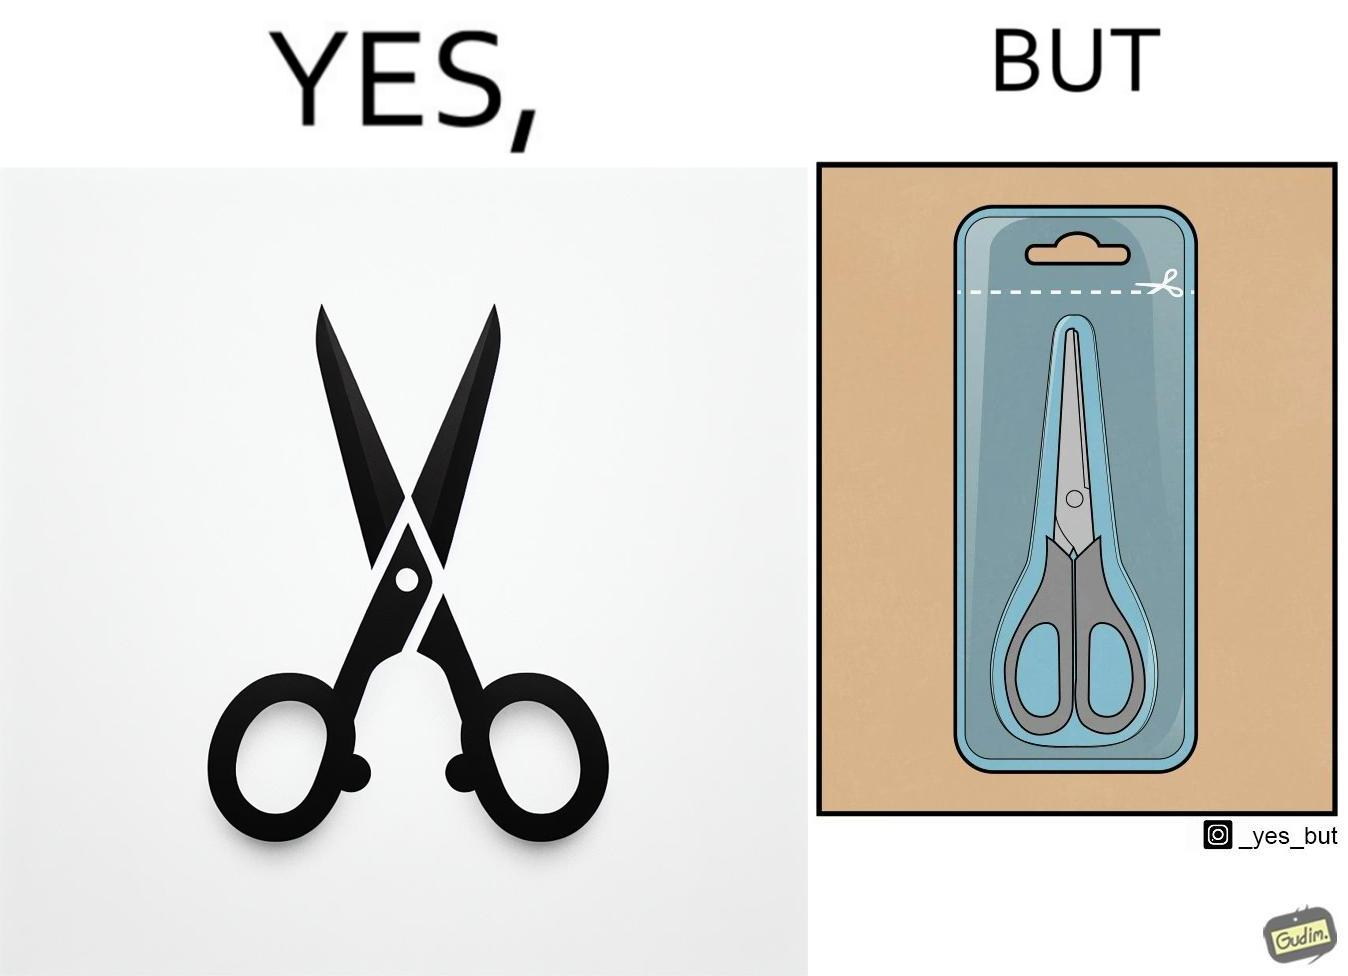What makes this image funny or satirical? the image is funny, as the marking at the top of the packaging shows that you would need a pair of scissors to in-turn cut open the pair of scissors that is inside the packaging. 